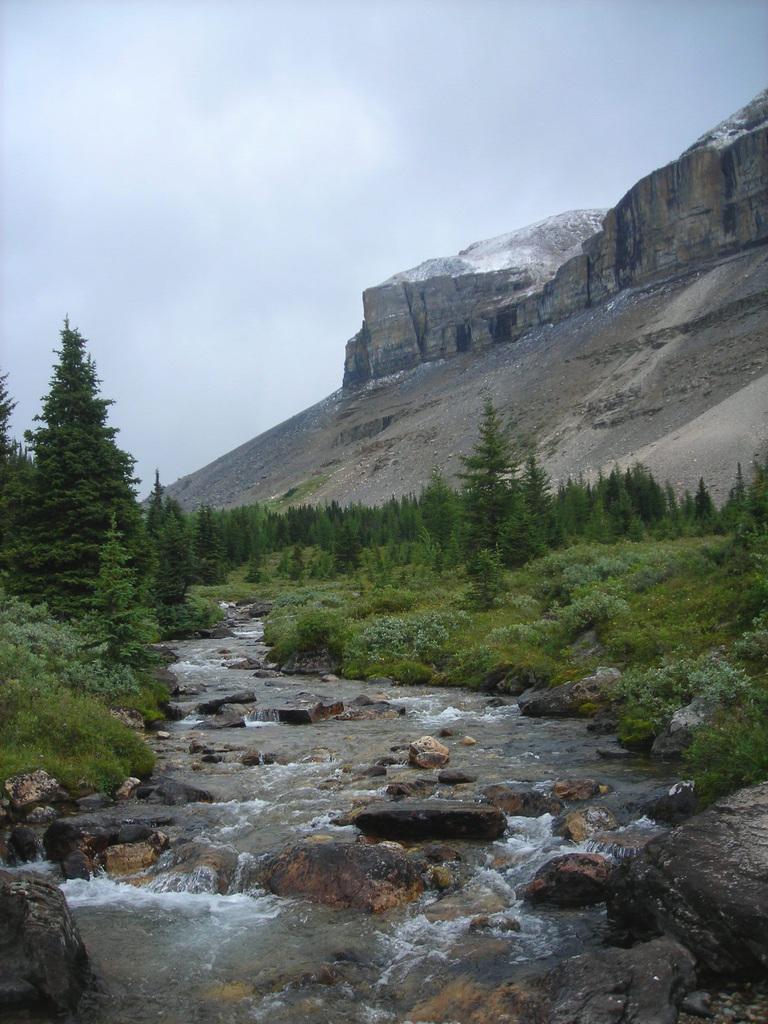In one or two sentences, can you explain what this image depicts? In this image there are trees in the middle of them there is a water flow and there are some rocks. In the background there is a mountain and the sky. 